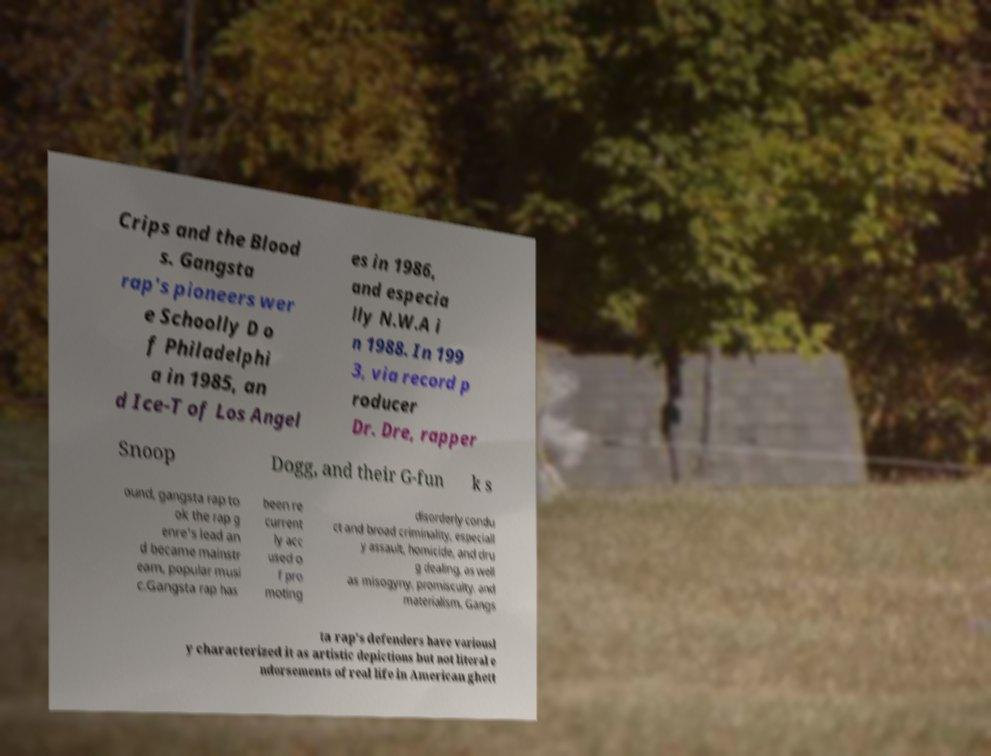Can you read and provide the text displayed in the image?This photo seems to have some interesting text. Can you extract and type it out for me? Crips and the Blood s. Gangsta rap's pioneers wer e Schoolly D o f Philadelphi a in 1985, an d Ice-T of Los Angel es in 1986, and especia lly N.W.A i n 1988. In 199 3, via record p roducer Dr. Dre, rapper Snoop Dogg, and their G-fun k s ound, gangsta rap to ok the rap g enre's lead an d became mainstr eam, popular musi c.Gangsta rap has been re current ly acc used o f pro moting disorderly condu ct and broad criminality, especiall y assault, homicide, and dru g dealing, as well as misogyny, promiscuity, and materialism. Gangs ta rap's defenders have variousl y characterized it as artistic depictions but not literal e ndorsements of real life in American ghett 